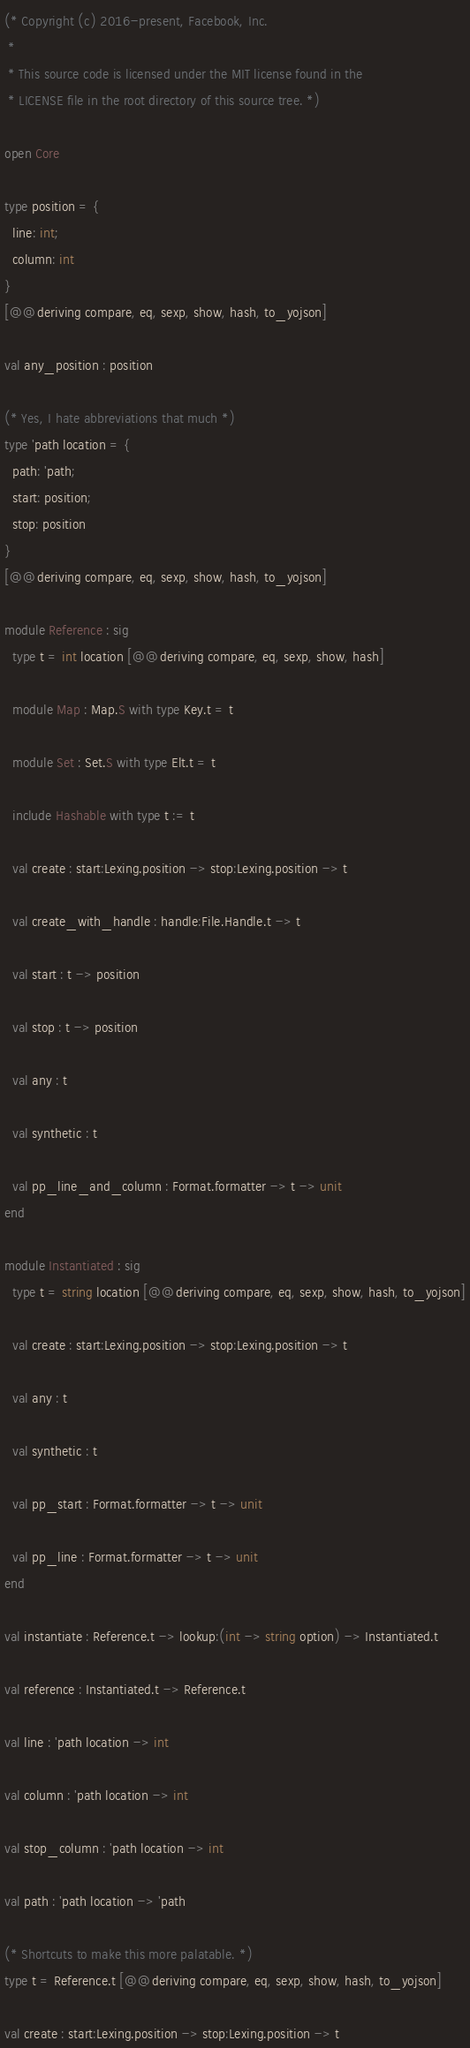Convert code to text. <code><loc_0><loc_0><loc_500><loc_500><_OCaml_>(* Copyright (c) 2016-present, Facebook, Inc.
 *
 * This source code is licensed under the MIT license found in the
 * LICENSE file in the root directory of this source tree. *)

open Core

type position = {
  line: int;
  column: int
}
[@@deriving compare, eq, sexp, show, hash, to_yojson]

val any_position : position

(* Yes, I hate abbreviations that much *)
type 'path location = {
  path: 'path;
  start: position;
  stop: position
}
[@@deriving compare, eq, sexp, show, hash, to_yojson]

module Reference : sig
  type t = int location [@@deriving compare, eq, sexp, show, hash]

  module Map : Map.S with type Key.t = t

  module Set : Set.S with type Elt.t = t

  include Hashable with type t := t

  val create : start:Lexing.position -> stop:Lexing.position -> t

  val create_with_handle : handle:File.Handle.t -> t

  val start : t -> position

  val stop : t -> position

  val any : t

  val synthetic : t

  val pp_line_and_column : Format.formatter -> t -> unit
end

module Instantiated : sig
  type t = string location [@@deriving compare, eq, sexp, show, hash, to_yojson]

  val create : start:Lexing.position -> stop:Lexing.position -> t

  val any : t

  val synthetic : t

  val pp_start : Format.formatter -> t -> unit

  val pp_line : Format.formatter -> t -> unit
end

val instantiate : Reference.t -> lookup:(int -> string option) -> Instantiated.t

val reference : Instantiated.t -> Reference.t

val line : 'path location -> int

val column : 'path location -> int

val stop_column : 'path location -> int

val path : 'path location -> 'path

(* Shortcuts to make this more palatable. *)
type t = Reference.t [@@deriving compare, eq, sexp, show, hash, to_yojson]

val create : start:Lexing.position -> stop:Lexing.position -> t
</code> 